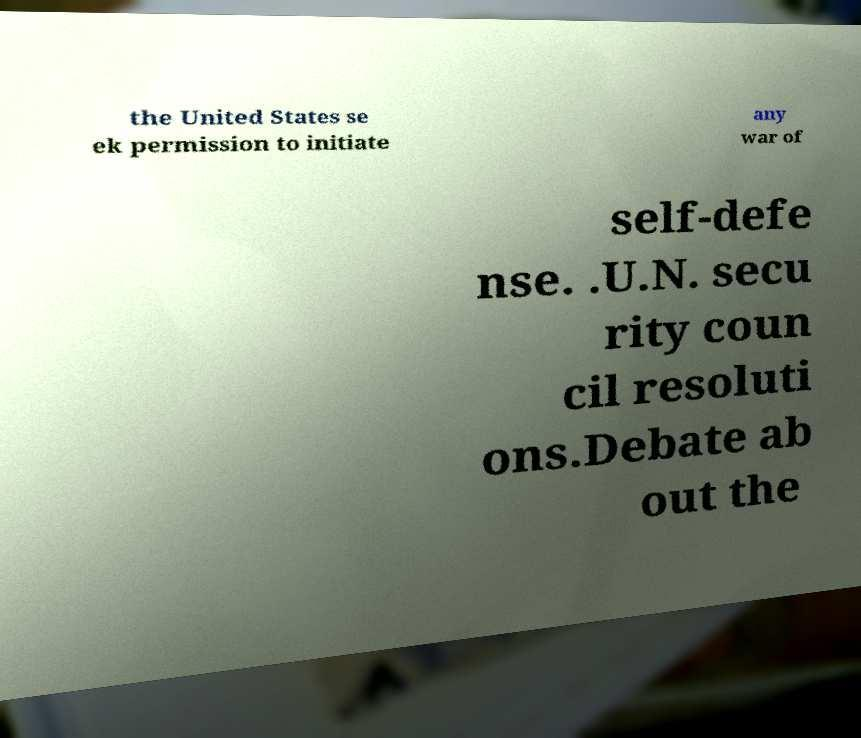Could you assist in decoding the text presented in this image and type it out clearly? the United States se ek permission to initiate any war of self-defe nse. .U.N. secu rity coun cil resoluti ons.Debate ab out the 